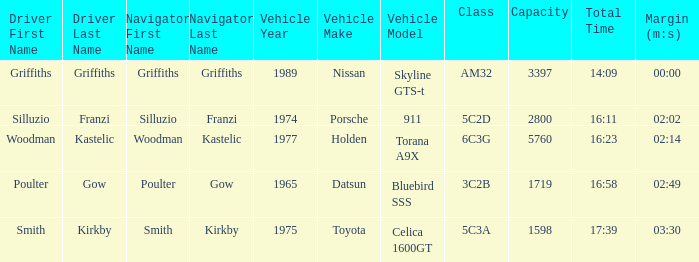What is the lowest capacity for the 1975 toyota celica 1600gt? 1598.0. 